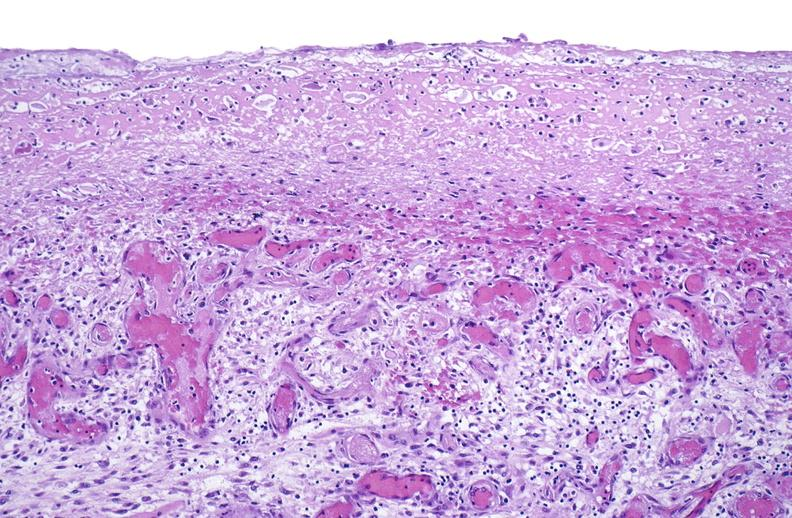s muscle present?
Answer the question using a single word or phrase. Yes 